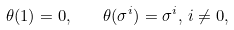Convert formula to latex. <formula><loc_0><loc_0><loc_500><loc_500>\theta ( 1 ) = 0 , \quad \theta ( \sigma ^ { i } ) = \sigma ^ { i } , \, i \neq 0 ,</formula> 